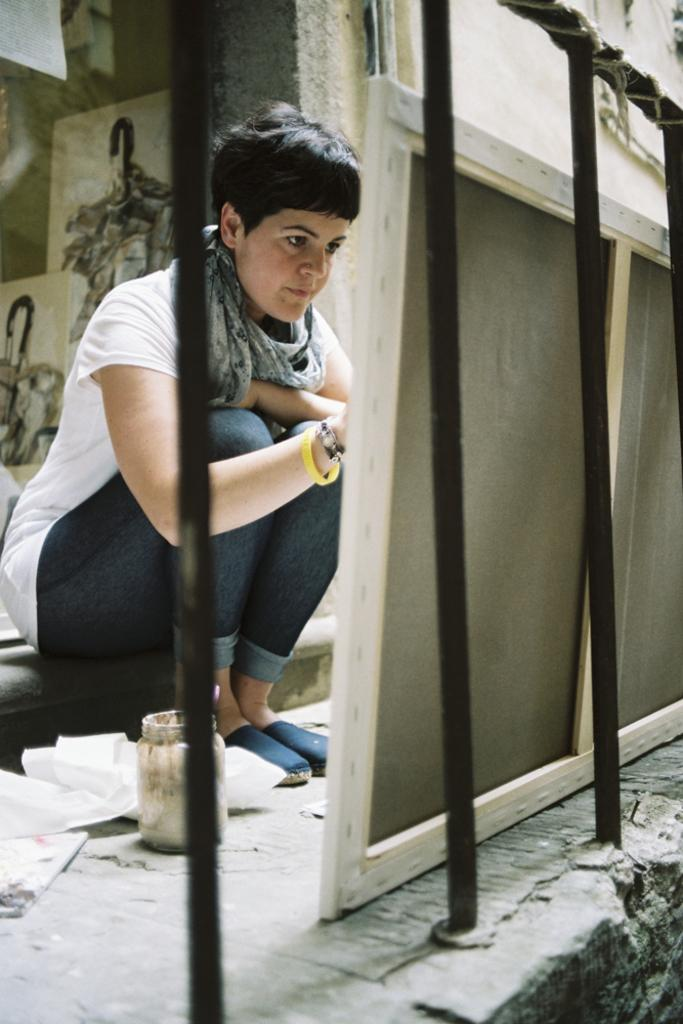What type of barrier can be seen in the image? There is a fence in the image. Who is located behind the fence? There is a woman behind the fence. What object is visible in the image? There is a bottle visible in the image. What type of structure is present in the image? There are boards and a wall in the image. What are the posts on the wall used for? The posts on the wall are used to support the wall. What might be present on the left side of the image? It appears there are papers on the left side of the image. How does the woman behind the fence feel about the wave in the image? There is no wave present in the image, so it is not possible to determine how the woman feels about it. What is the digestive process of the papers on the left side of the image? The papers are not living organisms, so they do not have a digestive process. 